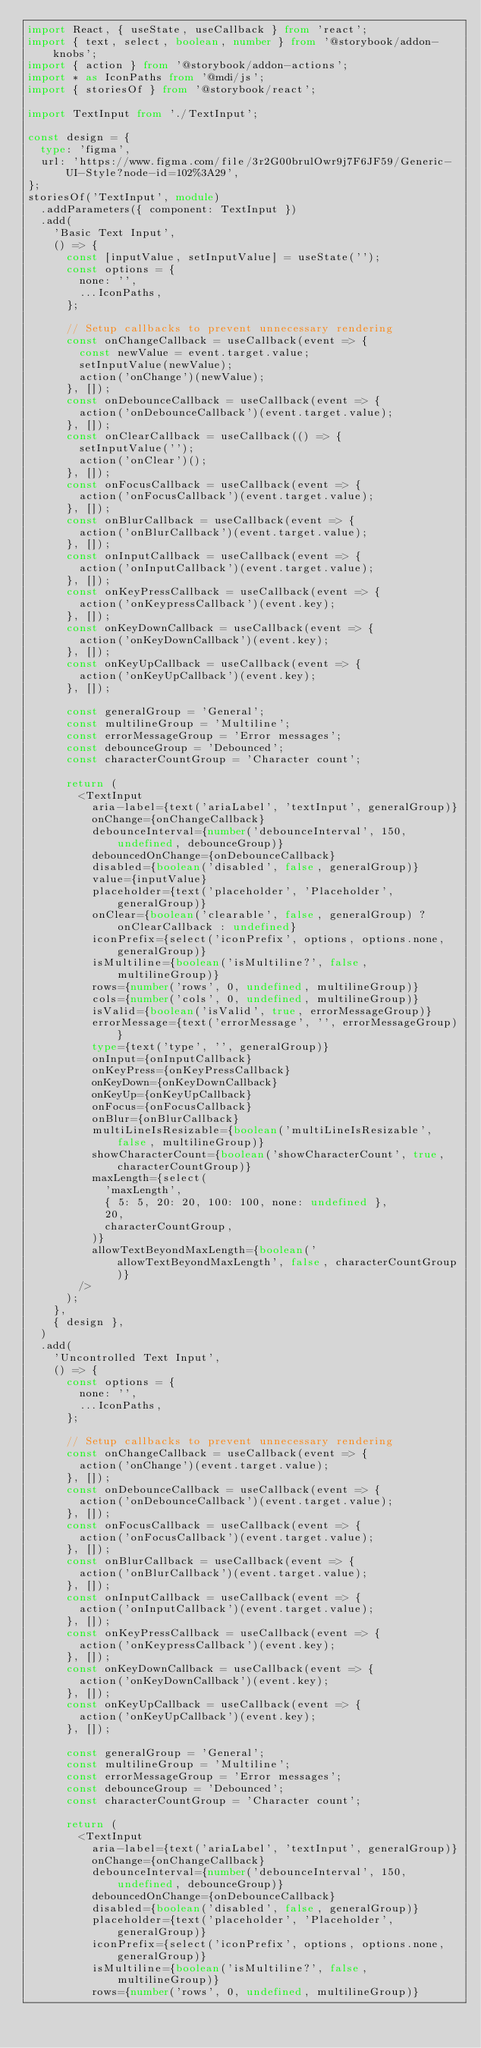<code> <loc_0><loc_0><loc_500><loc_500><_TypeScript_>import React, { useState, useCallback } from 'react';
import { text, select, boolean, number } from '@storybook/addon-knobs';
import { action } from '@storybook/addon-actions';
import * as IconPaths from '@mdi/js';
import { storiesOf } from '@storybook/react';

import TextInput from './TextInput';

const design = {
  type: 'figma',
  url: 'https://www.figma.com/file/3r2G00brulOwr9j7F6JF59/Generic-UI-Style?node-id=102%3A29',
};
storiesOf('TextInput', module)
  .addParameters({ component: TextInput })
  .add(
    'Basic Text Input',
    () => {
      const [inputValue, setInputValue] = useState('');
      const options = {
        none: '',
        ...IconPaths,
      };

      // Setup callbacks to prevent unnecessary rendering
      const onChangeCallback = useCallback(event => {
        const newValue = event.target.value;
        setInputValue(newValue);
        action('onChange')(newValue);
      }, []);
      const onDebounceCallback = useCallback(event => {
        action('onDebounceCallback')(event.target.value);
      }, []);
      const onClearCallback = useCallback(() => {
        setInputValue('');
        action('onClear')();
      }, []);
      const onFocusCallback = useCallback(event => {
        action('onFocusCallback')(event.target.value);
      }, []);
      const onBlurCallback = useCallback(event => {
        action('onBlurCallback')(event.target.value);
      }, []);
      const onInputCallback = useCallback(event => {
        action('onInputCallback')(event.target.value);
      }, []);
      const onKeyPressCallback = useCallback(event => {
        action('onKeypressCallback')(event.key);
      }, []);
      const onKeyDownCallback = useCallback(event => {
        action('onKeyDownCallback')(event.key);
      }, []);
      const onKeyUpCallback = useCallback(event => {
        action('onKeyUpCallback')(event.key);
      }, []);

      const generalGroup = 'General';
      const multilineGroup = 'Multiline';
      const errorMessageGroup = 'Error messages';
      const debounceGroup = 'Debounced';
      const characterCountGroup = 'Character count';

      return (
        <TextInput
          aria-label={text('ariaLabel', 'textInput', generalGroup)}
          onChange={onChangeCallback}
          debounceInterval={number('debounceInterval', 150, undefined, debounceGroup)}
          debouncedOnChange={onDebounceCallback}
          disabled={boolean('disabled', false, generalGroup)}
          value={inputValue}
          placeholder={text('placeholder', 'Placeholder', generalGroup)}
          onClear={boolean('clearable', false, generalGroup) ? onClearCallback : undefined}
          iconPrefix={select('iconPrefix', options, options.none, generalGroup)}
          isMultiline={boolean('isMultiline?', false, multilineGroup)}
          rows={number('rows', 0, undefined, multilineGroup)}
          cols={number('cols', 0, undefined, multilineGroup)}
          isValid={boolean('isValid', true, errorMessageGroup)}
          errorMessage={text('errorMessage', '', errorMessageGroup)}
          type={text('type', '', generalGroup)}
          onInput={onInputCallback}
          onKeyPress={onKeyPressCallback}
          onKeyDown={onKeyDownCallback}
          onKeyUp={onKeyUpCallback}
          onFocus={onFocusCallback}
          onBlur={onBlurCallback}
          multiLineIsResizable={boolean('multiLineIsResizable', false, multilineGroup)}
          showCharacterCount={boolean('showCharacterCount', true, characterCountGroup)}
          maxLength={select(
            'maxLength',
            { 5: 5, 20: 20, 100: 100, none: undefined },
            20,
            characterCountGroup,
          )}
          allowTextBeyondMaxLength={boolean('allowTextBeyondMaxLength', false, characterCountGroup)}
        />
      );
    },
    { design },
  )
  .add(
    'Uncontrolled Text Input',
    () => {
      const options = {
        none: '',
        ...IconPaths,
      };

      // Setup callbacks to prevent unnecessary rendering
      const onChangeCallback = useCallback(event => {
        action('onChange')(event.target.value);
      }, []);
      const onDebounceCallback = useCallback(event => {
        action('onDebounceCallback')(event.target.value);
      }, []);
      const onFocusCallback = useCallback(event => {
        action('onFocusCallback')(event.target.value);
      }, []);
      const onBlurCallback = useCallback(event => {
        action('onBlurCallback')(event.target.value);
      }, []);
      const onInputCallback = useCallback(event => {
        action('onInputCallback')(event.target.value);
      }, []);
      const onKeyPressCallback = useCallback(event => {
        action('onKeypressCallback')(event.key);
      }, []);
      const onKeyDownCallback = useCallback(event => {
        action('onKeyDownCallback')(event.key);
      }, []);
      const onKeyUpCallback = useCallback(event => {
        action('onKeyUpCallback')(event.key);
      }, []);

      const generalGroup = 'General';
      const multilineGroup = 'Multiline';
      const errorMessageGroup = 'Error messages';
      const debounceGroup = 'Debounced';
      const characterCountGroup = 'Character count';

      return (
        <TextInput
          aria-label={text('ariaLabel', 'textInput', generalGroup)}
          onChange={onChangeCallback}
          debounceInterval={number('debounceInterval', 150, undefined, debounceGroup)}
          debouncedOnChange={onDebounceCallback}
          disabled={boolean('disabled', false, generalGroup)}
          placeholder={text('placeholder', 'Placeholder', generalGroup)}
          iconPrefix={select('iconPrefix', options, options.none, generalGroup)}
          isMultiline={boolean('isMultiline?', false, multilineGroup)}
          rows={number('rows', 0, undefined, multilineGroup)}</code> 